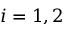Convert formula to latex. <formula><loc_0><loc_0><loc_500><loc_500>i = 1 , 2</formula> 